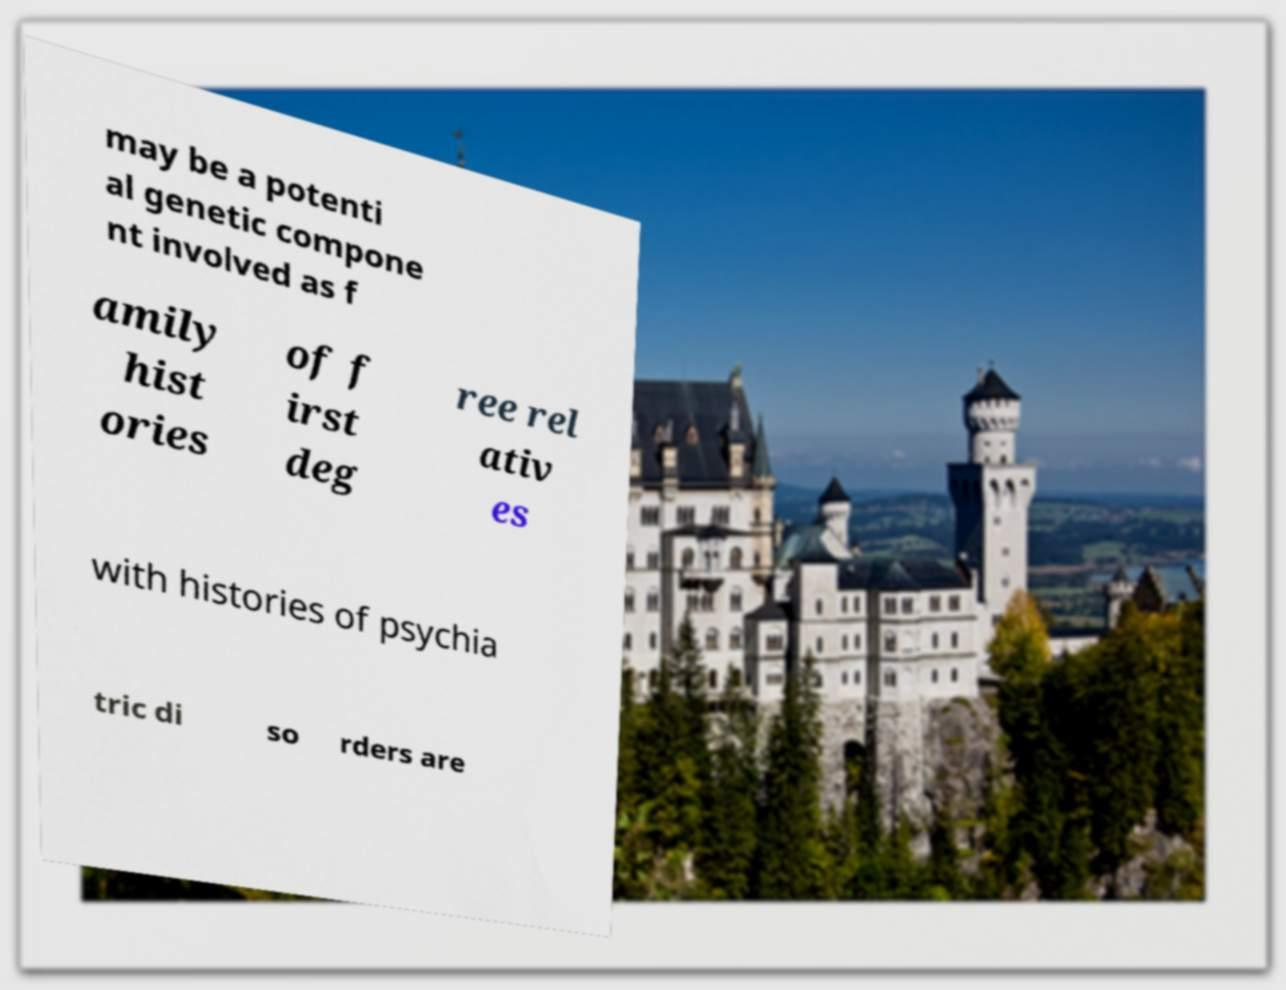Can you read and provide the text displayed in the image?This photo seems to have some interesting text. Can you extract and type it out for me? may be a potenti al genetic compone nt involved as f amily hist ories of f irst deg ree rel ativ es with histories of psychia tric di so rders are 